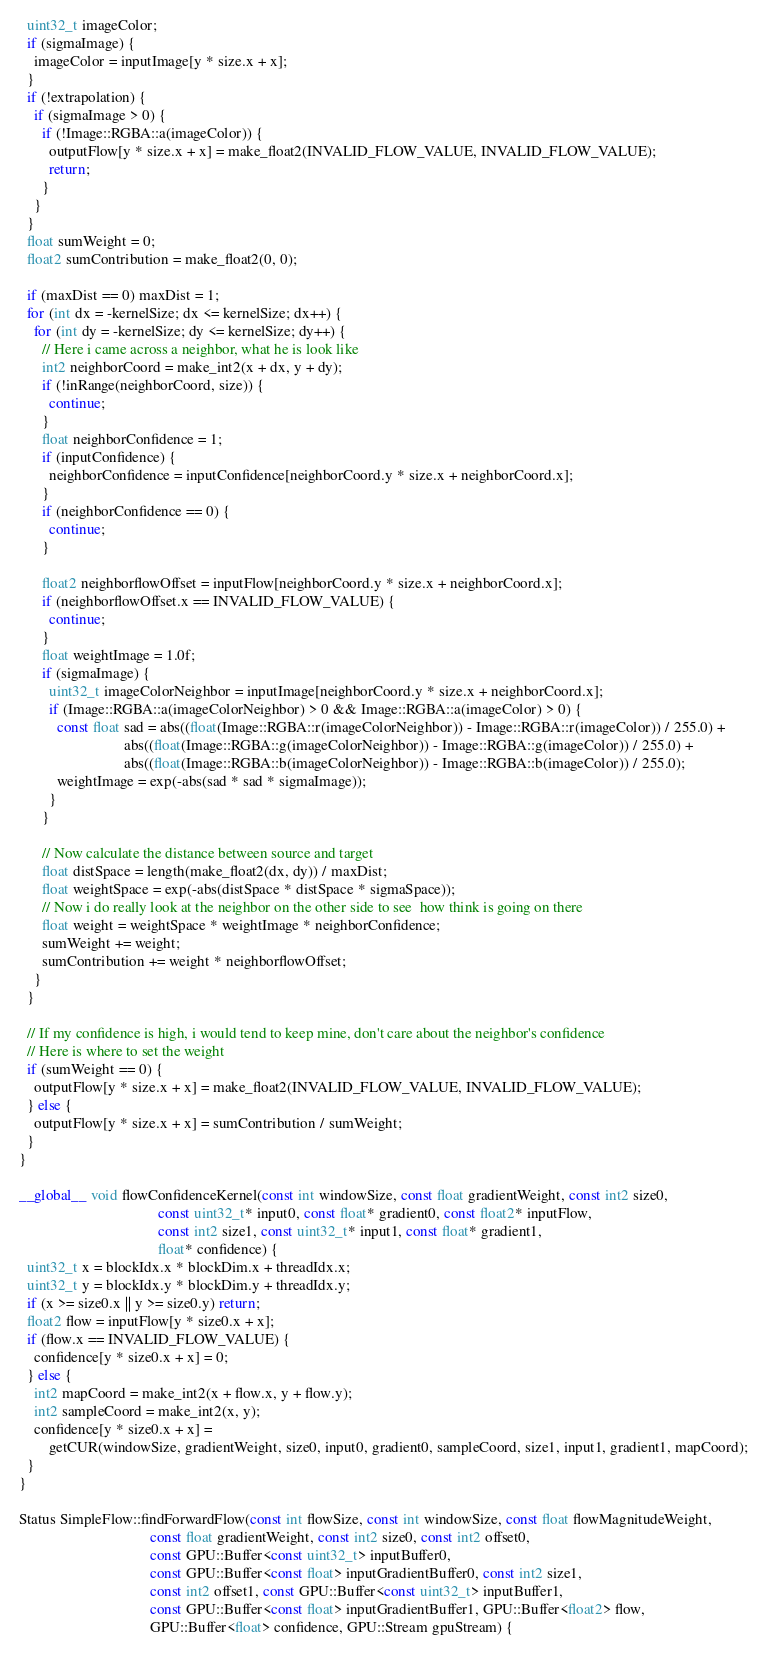Convert code to text. <code><loc_0><loc_0><loc_500><loc_500><_Cuda_>  uint32_t imageColor;
  if (sigmaImage) {
    imageColor = inputImage[y * size.x + x];
  }
  if (!extrapolation) {
    if (sigmaImage > 0) {
      if (!Image::RGBA::a(imageColor)) {
        outputFlow[y * size.x + x] = make_float2(INVALID_FLOW_VALUE, INVALID_FLOW_VALUE);
        return;
      }
    }
  }
  float sumWeight = 0;
  float2 sumContribution = make_float2(0, 0);

  if (maxDist == 0) maxDist = 1;
  for (int dx = -kernelSize; dx <= kernelSize; dx++) {
    for (int dy = -kernelSize; dy <= kernelSize; dy++) {
      // Here i came across a neighbor, what he is look like
      int2 neighborCoord = make_int2(x + dx, y + dy);
      if (!inRange(neighborCoord, size)) {
        continue;
      }
      float neighborConfidence = 1;
      if (inputConfidence) {
        neighborConfidence = inputConfidence[neighborCoord.y * size.x + neighborCoord.x];
      }
      if (neighborConfidence == 0) {
        continue;
      }

      float2 neighborflowOffset = inputFlow[neighborCoord.y * size.x + neighborCoord.x];
      if (neighborflowOffset.x == INVALID_FLOW_VALUE) {
        continue;
      }
      float weightImage = 1.0f;
      if (sigmaImage) {
        uint32_t imageColorNeighbor = inputImage[neighborCoord.y * size.x + neighborCoord.x];
        if (Image::RGBA::a(imageColorNeighbor) > 0 && Image::RGBA::a(imageColor) > 0) {
          const float sad = abs((float(Image::RGBA::r(imageColorNeighbor)) - Image::RGBA::r(imageColor)) / 255.0) +
                            abs((float(Image::RGBA::g(imageColorNeighbor)) - Image::RGBA::g(imageColor)) / 255.0) +
                            abs((float(Image::RGBA::b(imageColorNeighbor)) - Image::RGBA::b(imageColor)) / 255.0);
          weightImage = exp(-abs(sad * sad * sigmaImage));
        }
      }

      // Now calculate the distance between source and target
      float distSpace = length(make_float2(dx, dy)) / maxDist;
      float weightSpace = exp(-abs(distSpace * distSpace * sigmaSpace));
      // Now i do really look at the neighbor on the other side to see  how think is going on there
      float weight = weightSpace * weightImage * neighborConfidence;
      sumWeight += weight;
      sumContribution += weight * neighborflowOffset;
    }
  }

  // If my confidence is high, i would tend to keep mine, don't care about the neighbor's confidence
  // Here is where to set the weight
  if (sumWeight == 0) {
    outputFlow[y * size.x + x] = make_float2(INVALID_FLOW_VALUE, INVALID_FLOW_VALUE);
  } else {
    outputFlow[y * size.x + x] = sumContribution / sumWeight;
  }
}

__global__ void flowConfidenceKernel(const int windowSize, const float gradientWeight, const int2 size0,
                                     const uint32_t* input0, const float* gradient0, const float2* inputFlow,
                                     const int2 size1, const uint32_t* input1, const float* gradient1,
                                     float* confidence) {
  uint32_t x = blockIdx.x * blockDim.x + threadIdx.x;
  uint32_t y = blockIdx.y * blockDim.y + threadIdx.y;
  if (x >= size0.x || y >= size0.y) return;
  float2 flow = inputFlow[y * size0.x + x];
  if (flow.x == INVALID_FLOW_VALUE) {
    confidence[y * size0.x + x] = 0;
  } else {
    int2 mapCoord = make_int2(x + flow.x, y + flow.y);
    int2 sampleCoord = make_int2(x, y);
    confidence[y * size0.x + x] =
        getCUR(windowSize, gradientWeight, size0, input0, gradient0, sampleCoord, size1, input1, gradient1, mapCoord);
  }
}

Status SimpleFlow::findForwardFlow(const int flowSize, const int windowSize, const float flowMagnitudeWeight,
                                   const float gradientWeight, const int2 size0, const int2 offset0,
                                   const GPU::Buffer<const uint32_t> inputBuffer0,
                                   const GPU::Buffer<const float> inputGradientBuffer0, const int2 size1,
                                   const int2 offset1, const GPU::Buffer<const uint32_t> inputBuffer1,
                                   const GPU::Buffer<const float> inputGradientBuffer1, GPU::Buffer<float2> flow,
                                   GPU::Buffer<float> confidence, GPU::Stream gpuStream) {</code> 